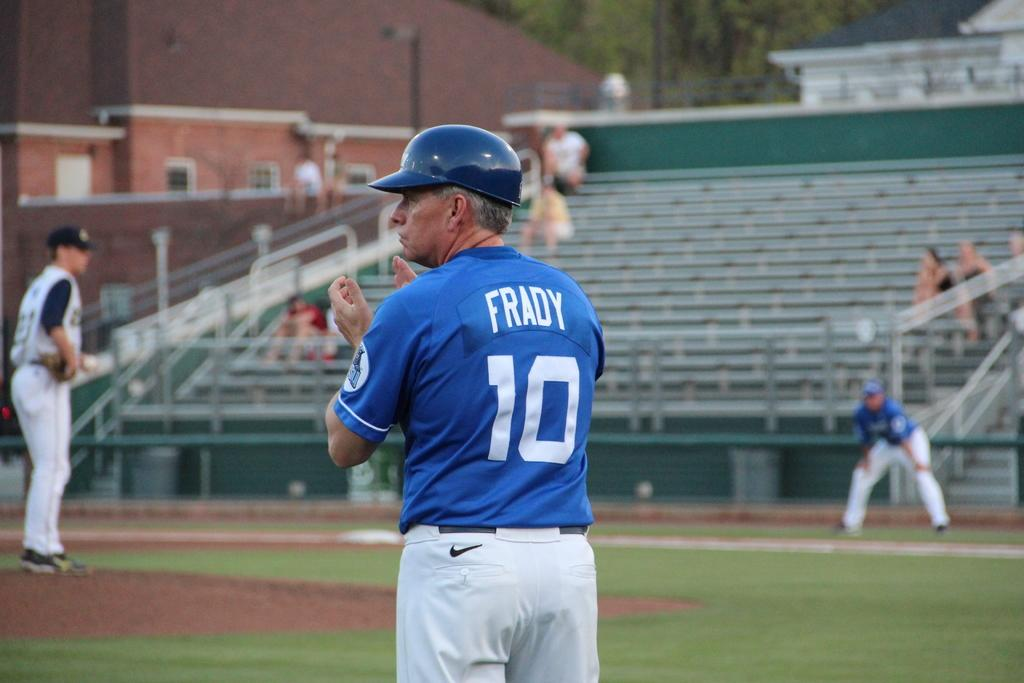<image>
Summarize the visual content of the image. The third base coach Frady claps his hands. 